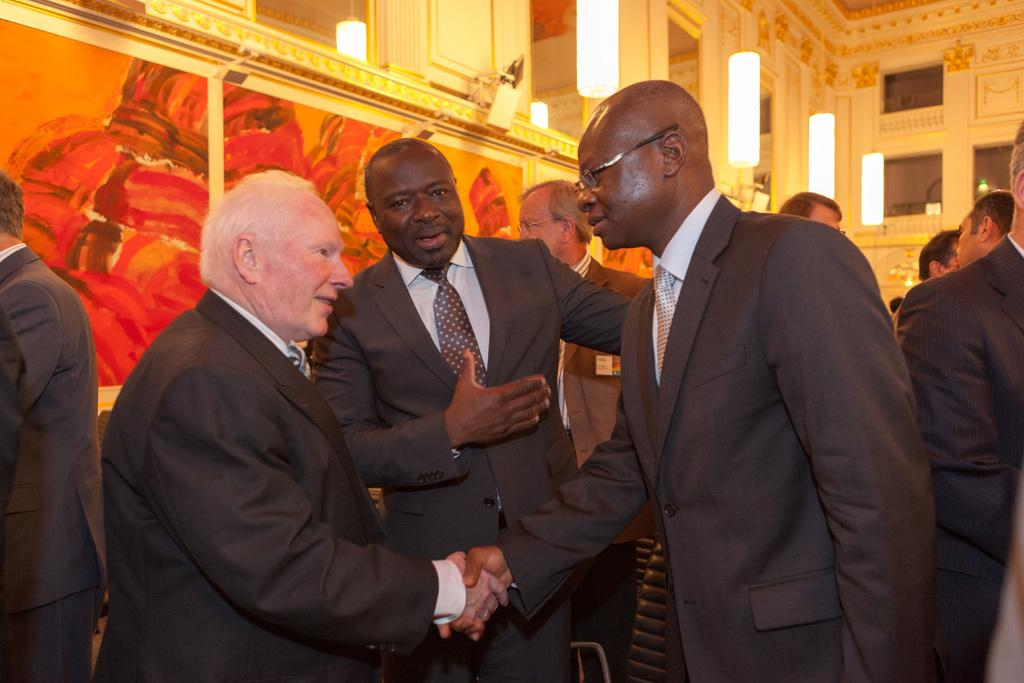What can be seen in the image? There are men standing in the image. What is visible in the background? There is a wall with frames and pillars visible in the background. Are there any lighting features in the background? Yes, there are lights present in the background. What color is the cow standing next to the men in the image? There is no cow present in the image; it only features men standing. 